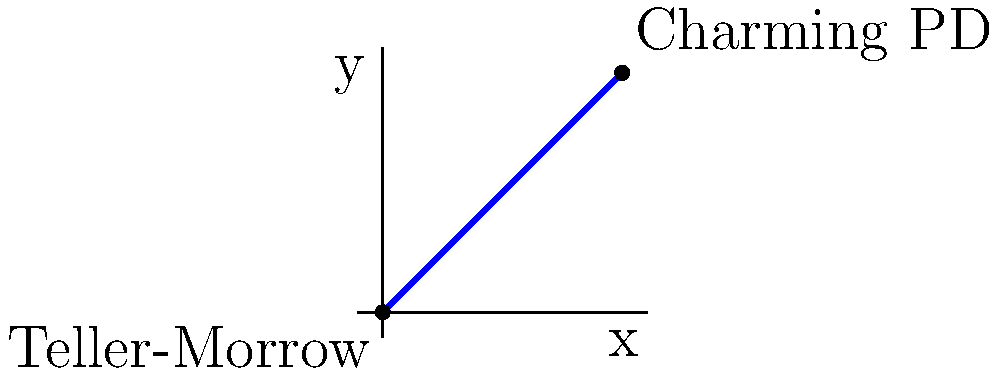Jax Teller needs to ride his motorcycle from Teller-Morrow Auto Shop to Charming Police Department. On a coordinate plane, Teller-Morrow is located at $(0,0)$ and the Charming PD is at $(10,10)$. Assuming Jax takes the most direct route, what is the equation of the line representing his path through Charming? To find the equation of the line, we'll use the point-slope form and then convert it to slope-intercept form.

1. Calculate the slope:
   Slope $m = \frac{y_2 - y_1}{x_2 - x_1} = \frac{10 - 0}{10 - 0} = 1$

2. Use the point-slope form with $(0,0)$ as the known point:
   $y - y_1 = m(x - x_1)$
   $y - 0 = 1(x - 0)$

3. Simplify:
   $y = x$

4. This is already in slope-intercept form $(y = mx + b)$, where $m = 1$ and $b = 0$.

Therefore, the equation of the line representing Jax's path through Charming is $y = x$.
Answer: $y = x$ 